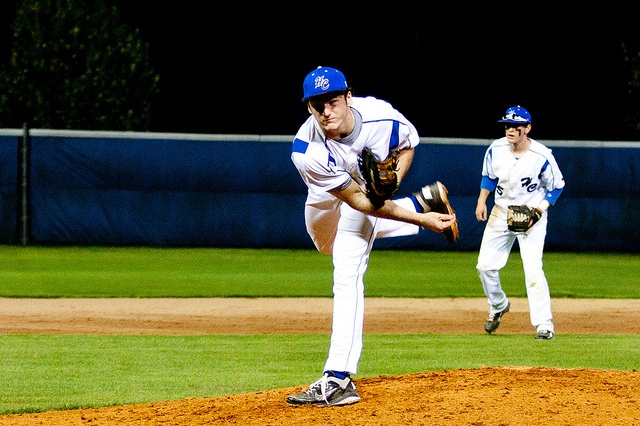Describe the objects in this image and their specific colors. I can see people in black, white, darkgray, and brown tones, people in black, white, darkgray, and tan tones, baseball glove in black, maroon, and olive tones, and baseball glove in black, tan, darkgreen, and gray tones in this image. 